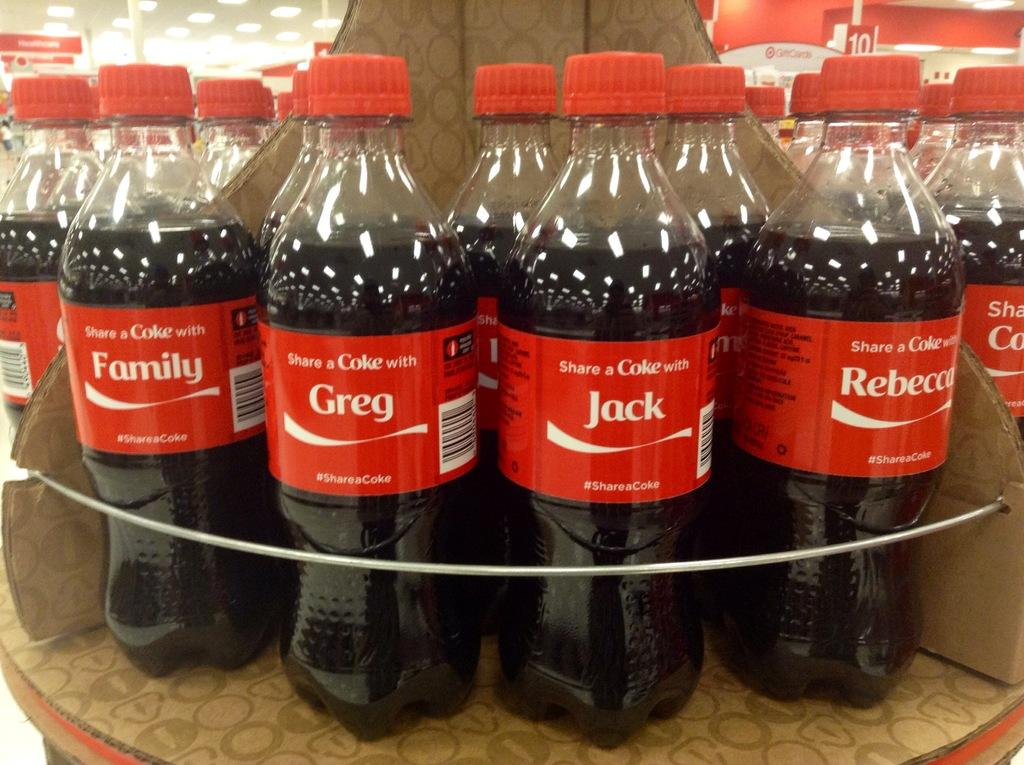<image>
Share a concise interpretation of the image provided. bottles of Coke with people's names like Jack and Greg 